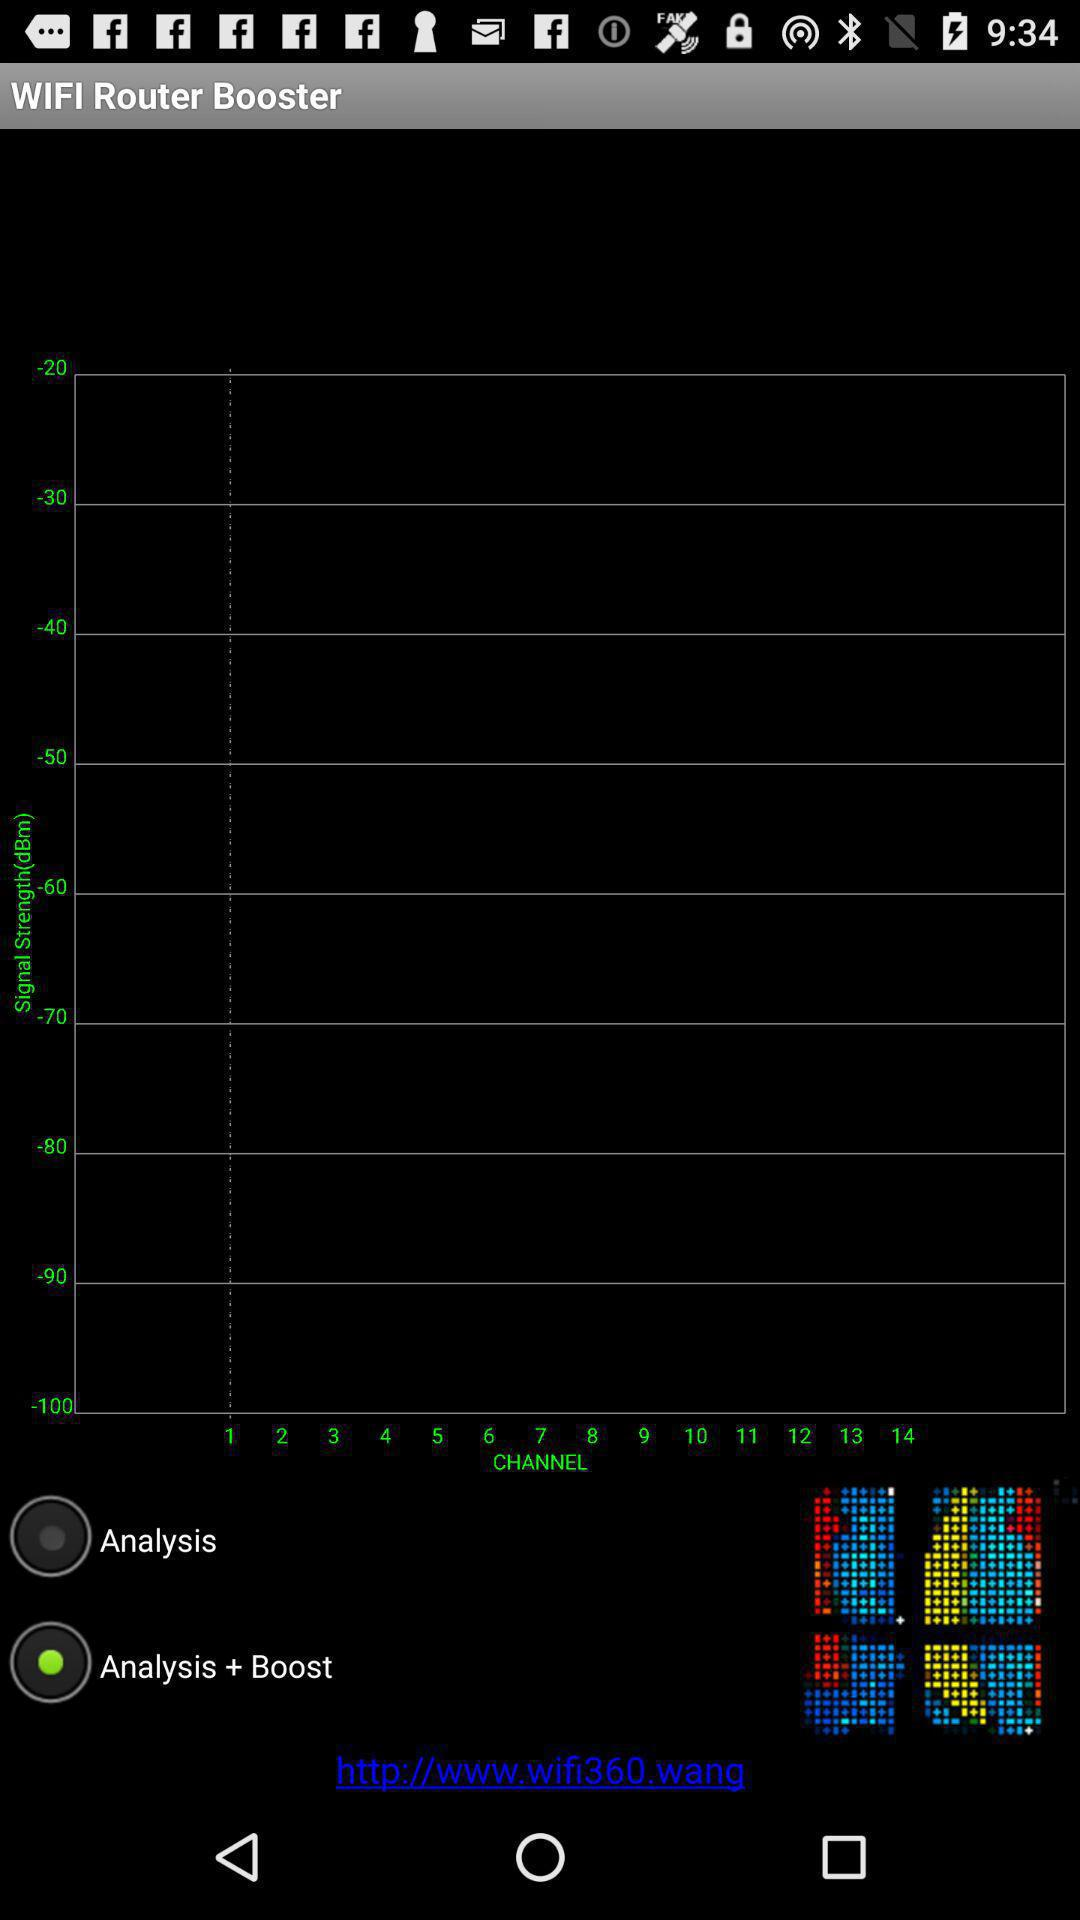How many data points are there?
When the provided information is insufficient, respond with <no answer>. <no answer> 